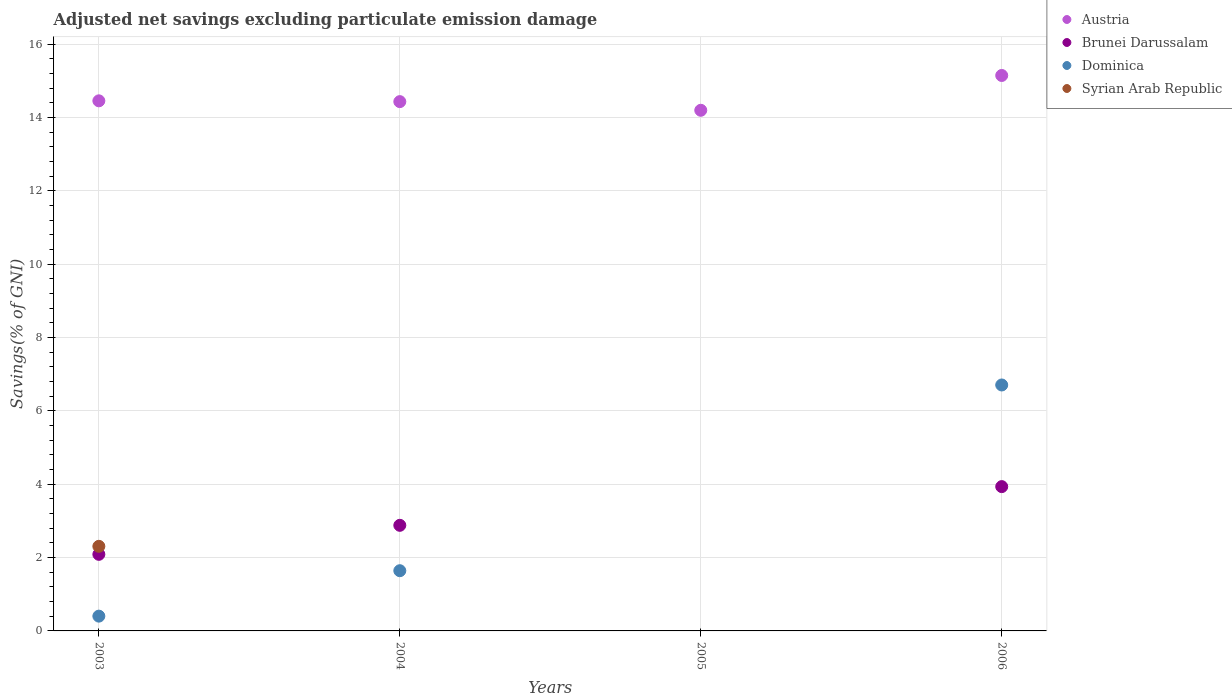Is the number of dotlines equal to the number of legend labels?
Keep it short and to the point. No. What is the adjusted net savings in Austria in 2003?
Keep it short and to the point. 14.45. Across all years, what is the maximum adjusted net savings in Austria?
Your answer should be compact. 15.14. In which year was the adjusted net savings in Dominica maximum?
Offer a terse response. 2006. What is the total adjusted net savings in Dominica in the graph?
Ensure brevity in your answer.  8.75. What is the difference between the adjusted net savings in Austria in 2003 and that in 2006?
Your answer should be compact. -0.69. What is the difference between the adjusted net savings in Austria in 2003 and the adjusted net savings in Syrian Arab Republic in 2005?
Your response must be concise. 14.45. What is the average adjusted net savings in Syrian Arab Republic per year?
Your response must be concise. 0.58. In the year 2003, what is the difference between the adjusted net savings in Brunei Darussalam and adjusted net savings in Dominica?
Give a very brief answer. 1.69. In how many years, is the adjusted net savings in Austria greater than 13.2 %?
Give a very brief answer. 4. What is the ratio of the adjusted net savings in Brunei Darussalam in 2003 to that in 2004?
Ensure brevity in your answer.  0.73. What is the difference between the highest and the second highest adjusted net savings in Dominica?
Ensure brevity in your answer.  5.06. What is the difference between the highest and the lowest adjusted net savings in Syrian Arab Republic?
Provide a succinct answer. 2.31. In how many years, is the adjusted net savings in Syrian Arab Republic greater than the average adjusted net savings in Syrian Arab Republic taken over all years?
Offer a very short reply. 1. Is the sum of the adjusted net savings in Austria in 2003 and 2006 greater than the maximum adjusted net savings in Brunei Darussalam across all years?
Ensure brevity in your answer.  Yes. Is it the case that in every year, the sum of the adjusted net savings in Dominica and adjusted net savings in Syrian Arab Republic  is greater than the sum of adjusted net savings in Austria and adjusted net savings in Brunei Darussalam?
Your answer should be very brief. No. Is it the case that in every year, the sum of the adjusted net savings in Brunei Darussalam and adjusted net savings in Dominica  is greater than the adjusted net savings in Syrian Arab Republic?
Provide a succinct answer. No. Is the adjusted net savings in Austria strictly less than the adjusted net savings in Syrian Arab Republic over the years?
Offer a terse response. No. What is the difference between two consecutive major ticks on the Y-axis?
Offer a very short reply. 2. Are the values on the major ticks of Y-axis written in scientific E-notation?
Give a very brief answer. No. Does the graph contain any zero values?
Provide a succinct answer. Yes. Does the graph contain grids?
Your response must be concise. Yes. Where does the legend appear in the graph?
Keep it short and to the point. Top right. How many legend labels are there?
Give a very brief answer. 4. How are the legend labels stacked?
Your answer should be compact. Vertical. What is the title of the graph?
Your response must be concise. Adjusted net savings excluding particulate emission damage. Does "Lao PDR" appear as one of the legend labels in the graph?
Your answer should be very brief. No. What is the label or title of the X-axis?
Provide a short and direct response. Years. What is the label or title of the Y-axis?
Keep it short and to the point. Savings(% of GNI). What is the Savings(% of GNI) of Austria in 2003?
Make the answer very short. 14.45. What is the Savings(% of GNI) of Brunei Darussalam in 2003?
Provide a succinct answer. 2.09. What is the Savings(% of GNI) of Dominica in 2003?
Provide a short and direct response. 0.4. What is the Savings(% of GNI) of Syrian Arab Republic in 2003?
Provide a succinct answer. 2.31. What is the Savings(% of GNI) of Austria in 2004?
Offer a terse response. 14.43. What is the Savings(% of GNI) of Brunei Darussalam in 2004?
Give a very brief answer. 2.88. What is the Savings(% of GNI) in Dominica in 2004?
Make the answer very short. 1.64. What is the Savings(% of GNI) in Austria in 2005?
Keep it short and to the point. 14.2. What is the Savings(% of GNI) of Dominica in 2005?
Offer a very short reply. 0. What is the Savings(% of GNI) in Syrian Arab Republic in 2005?
Keep it short and to the point. 0. What is the Savings(% of GNI) of Austria in 2006?
Ensure brevity in your answer.  15.14. What is the Savings(% of GNI) of Brunei Darussalam in 2006?
Keep it short and to the point. 3.93. What is the Savings(% of GNI) in Dominica in 2006?
Your answer should be compact. 6.71. Across all years, what is the maximum Savings(% of GNI) in Austria?
Keep it short and to the point. 15.14. Across all years, what is the maximum Savings(% of GNI) of Brunei Darussalam?
Make the answer very short. 3.93. Across all years, what is the maximum Savings(% of GNI) in Dominica?
Make the answer very short. 6.71. Across all years, what is the maximum Savings(% of GNI) in Syrian Arab Republic?
Provide a succinct answer. 2.31. Across all years, what is the minimum Savings(% of GNI) of Austria?
Give a very brief answer. 14.2. Across all years, what is the minimum Savings(% of GNI) in Dominica?
Your answer should be very brief. 0. Across all years, what is the minimum Savings(% of GNI) of Syrian Arab Republic?
Your answer should be compact. 0. What is the total Savings(% of GNI) in Austria in the graph?
Make the answer very short. 58.23. What is the total Savings(% of GNI) in Brunei Darussalam in the graph?
Offer a terse response. 8.9. What is the total Savings(% of GNI) of Dominica in the graph?
Your answer should be compact. 8.75. What is the total Savings(% of GNI) in Syrian Arab Republic in the graph?
Give a very brief answer. 2.31. What is the difference between the Savings(% of GNI) of Austria in 2003 and that in 2004?
Offer a terse response. 0.02. What is the difference between the Savings(% of GNI) in Brunei Darussalam in 2003 and that in 2004?
Provide a succinct answer. -0.79. What is the difference between the Savings(% of GNI) in Dominica in 2003 and that in 2004?
Keep it short and to the point. -1.24. What is the difference between the Savings(% of GNI) in Austria in 2003 and that in 2005?
Your answer should be very brief. 0.26. What is the difference between the Savings(% of GNI) in Austria in 2003 and that in 2006?
Your answer should be very brief. -0.69. What is the difference between the Savings(% of GNI) in Brunei Darussalam in 2003 and that in 2006?
Make the answer very short. -1.85. What is the difference between the Savings(% of GNI) of Dominica in 2003 and that in 2006?
Keep it short and to the point. -6.3. What is the difference between the Savings(% of GNI) in Austria in 2004 and that in 2005?
Give a very brief answer. 0.24. What is the difference between the Savings(% of GNI) of Austria in 2004 and that in 2006?
Keep it short and to the point. -0.71. What is the difference between the Savings(% of GNI) in Brunei Darussalam in 2004 and that in 2006?
Keep it short and to the point. -1.06. What is the difference between the Savings(% of GNI) in Dominica in 2004 and that in 2006?
Provide a short and direct response. -5.06. What is the difference between the Savings(% of GNI) of Austria in 2005 and that in 2006?
Your response must be concise. -0.95. What is the difference between the Savings(% of GNI) in Austria in 2003 and the Savings(% of GNI) in Brunei Darussalam in 2004?
Provide a short and direct response. 11.57. What is the difference between the Savings(% of GNI) in Austria in 2003 and the Savings(% of GNI) in Dominica in 2004?
Give a very brief answer. 12.81. What is the difference between the Savings(% of GNI) in Brunei Darussalam in 2003 and the Savings(% of GNI) in Dominica in 2004?
Your response must be concise. 0.45. What is the difference between the Savings(% of GNI) of Austria in 2003 and the Savings(% of GNI) of Brunei Darussalam in 2006?
Your answer should be very brief. 10.52. What is the difference between the Savings(% of GNI) in Austria in 2003 and the Savings(% of GNI) in Dominica in 2006?
Your answer should be compact. 7.75. What is the difference between the Savings(% of GNI) of Brunei Darussalam in 2003 and the Savings(% of GNI) of Dominica in 2006?
Offer a very short reply. -4.62. What is the difference between the Savings(% of GNI) of Austria in 2004 and the Savings(% of GNI) of Brunei Darussalam in 2006?
Provide a short and direct response. 10.5. What is the difference between the Savings(% of GNI) in Austria in 2004 and the Savings(% of GNI) in Dominica in 2006?
Provide a succinct answer. 7.73. What is the difference between the Savings(% of GNI) in Brunei Darussalam in 2004 and the Savings(% of GNI) in Dominica in 2006?
Your answer should be compact. -3.83. What is the difference between the Savings(% of GNI) in Austria in 2005 and the Savings(% of GNI) in Brunei Darussalam in 2006?
Ensure brevity in your answer.  10.26. What is the difference between the Savings(% of GNI) in Austria in 2005 and the Savings(% of GNI) in Dominica in 2006?
Offer a terse response. 7.49. What is the average Savings(% of GNI) in Austria per year?
Provide a short and direct response. 14.56. What is the average Savings(% of GNI) in Brunei Darussalam per year?
Keep it short and to the point. 2.23. What is the average Savings(% of GNI) of Dominica per year?
Your answer should be compact. 2.19. What is the average Savings(% of GNI) of Syrian Arab Republic per year?
Your response must be concise. 0.58. In the year 2003, what is the difference between the Savings(% of GNI) of Austria and Savings(% of GNI) of Brunei Darussalam?
Give a very brief answer. 12.37. In the year 2003, what is the difference between the Savings(% of GNI) of Austria and Savings(% of GNI) of Dominica?
Offer a terse response. 14.05. In the year 2003, what is the difference between the Savings(% of GNI) in Austria and Savings(% of GNI) in Syrian Arab Republic?
Your response must be concise. 12.15. In the year 2003, what is the difference between the Savings(% of GNI) of Brunei Darussalam and Savings(% of GNI) of Dominica?
Provide a short and direct response. 1.69. In the year 2003, what is the difference between the Savings(% of GNI) in Brunei Darussalam and Savings(% of GNI) in Syrian Arab Republic?
Provide a succinct answer. -0.22. In the year 2003, what is the difference between the Savings(% of GNI) in Dominica and Savings(% of GNI) in Syrian Arab Republic?
Make the answer very short. -1.9. In the year 2004, what is the difference between the Savings(% of GNI) of Austria and Savings(% of GNI) of Brunei Darussalam?
Provide a succinct answer. 11.55. In the year 2004, what is the difference between the Savings(% of GNI) in Austria and Savings(% of GNI) in Dominica?
Give a very brief answer. 12.79. In the year 2004, what is the difference between the Savings(% of GNI) of Brunei Darussalam and Savings(% of GNI) of Dominica?
Make the answer very short. 1.24. In the year 2006, what is the difference between the Savings(% of GNI) of Austria and Savings(% of GNI) of Brunei Darussalam?
Offer a terse response. 11.21. In the year 2006, what is the difference between the Savings(% of GNI) in Austria and Savings(% of GNI) in Dominica?
Your response must be concise. 8.44. In the year 2006, what is the difference between the Savings(% of GNI) of Brunei Darussalam and Savings(% of GNI) of Dominica?
Provide a short and direct response. -2.77. What is the ratio of the Savings(% of GNI) of Austria in 2003 to that in 2004?
Provide a succinct answer. 1. What is the ratio of the Savings(% of GNI) in Brunei Darussalam in 2003 to that in 2004?
Your response must be concise. 0.73. What is the ratio of the Savings(% of GNI) in Dominica in 2003 to that in 2004?
Ensure brevity in your answer.  0.25. What is the ratio of the Savings(% of GNI) of Austria in 2003 to that in 2005?
Your answer should be compact. 1.02. What is the ratio of the Savings(% of GNI) in Austria in 2003 to that in 2006?
Ensure brevity in your answer.  0.95. What is the ratio of the Savings(% of GNI) in Brunei Darussalam in 2003 to that in 2006?
Ensure brevity in your answer.  0.53. What is the ratio of the Savings(% of GNI) of Dominica in 2003 to that in 2006?
Give a very brief answer. 0.06. What is the ratio of the Savings(% of GNI) in Austria in 2004 to that in 2005?
Keep it short and to the point. 1.02. What is the ratio of the Savings(% of GNI) in Austria in 2004 to that in 2006?
Your response must be concise. 0.95. What is the ratio of the Savings(% of GNI) in Brunei Darussalam in 2004 to that in 2006?
Ensure brevity in your answer.  0.73. What is the ratio of the Savings(% of GNI) of Dominica in 2004 to that in 2006?
Provide a short and direct response. 0.24. What is the ratio of the Savings(% of GNI) in Austria in 2005 to that in 2006?
Give a very brief answer. 0.94. What is the difference between the highest and the second highest Savings(% of GNI) of Austria?
Provide a short and direct response. 0.69. What is the difference between the highest and the second highest Savings(% of GNI) in Brunei Darussalam?
Give a very brief answer. 1.06. What is the difference between the highest and the second highest Savings(% of GNI) in Dominica?
Your answer should be very brief. 5.06. What is the difference between the highest and the lowest Savings(% of GNI) in Austria?
Give a very brief answer. 0.95. What is the difference between the highest and the lowest Savings(% of GNI) in Brunei Darussalam?
Provide a short and direct response. 3.93. What is the difference between the highest and the lowest Savings(% of GNI) of Dominica?
Your answer should be compact. 6.71. What is the difference between the highest and the lowest Savings(% of GNI) of Syrian Arab Republic?
Make the answer very short. 2.31. 